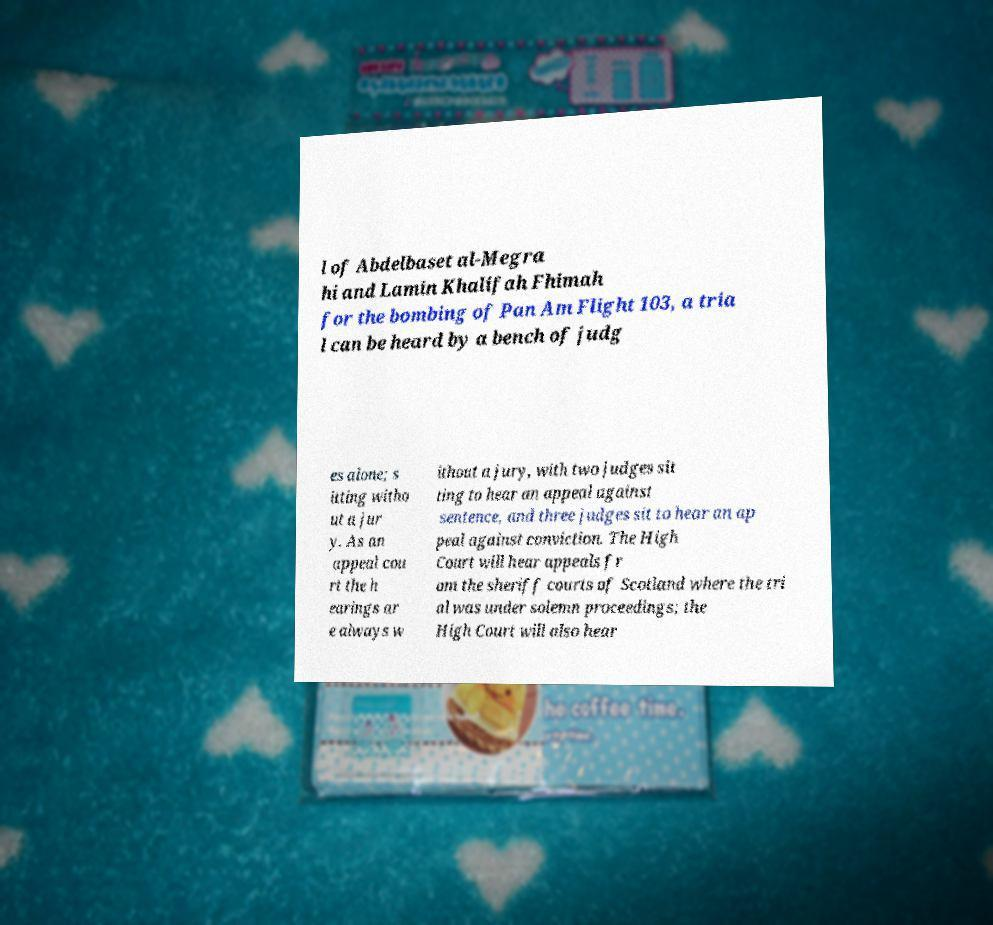Could you extract and type out the text from this image? l of Abdelbaset al-Megra hi and Lamin Khalifah Fhimah for the bombing of Pan Am Flight 103, a tria l can be heard by a bench of judg es alone; s itting witho ut a jur y. As an appeal cou rt the h earings ar e always w ithout a jury, with two judges sit ting to hear an appeal against sentence, and three judges sit to hear an ap peal against conviction. The High Court will hear appeals fr om the sheriff courts of Scotland where the tri al was under solemn proceedings; the High Court will also hear 